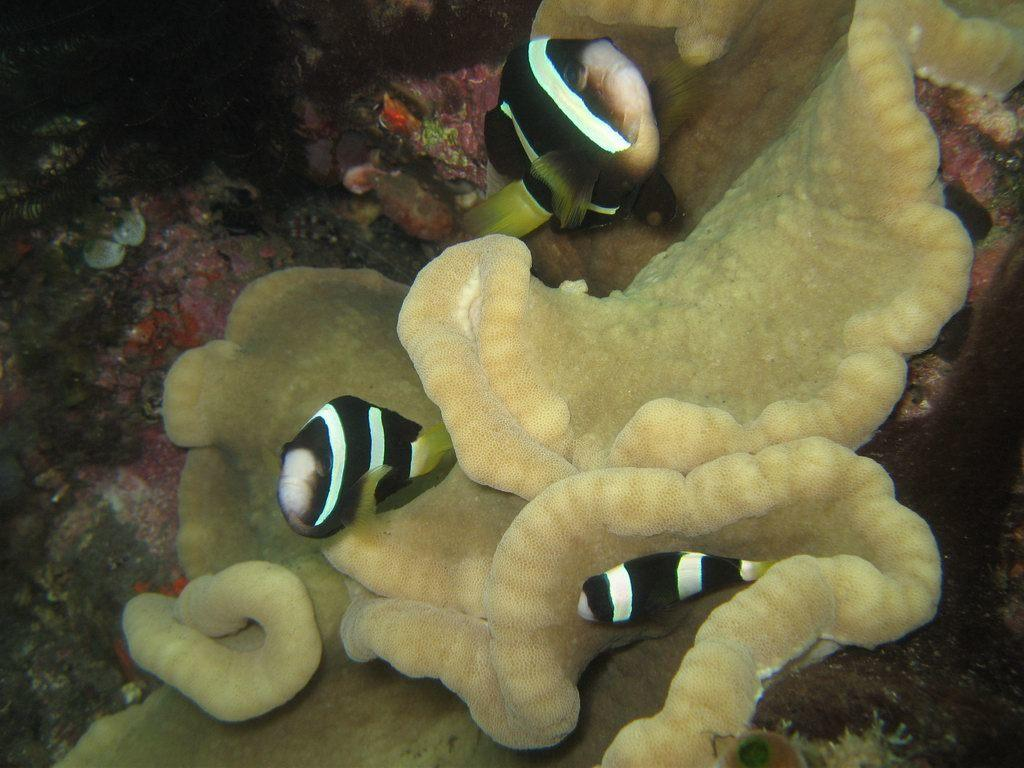What type of animals can be seen in the image? There are fishes swimming in the water. What other objects or structures can be seen in the water? There are stony corals visible. Are there any plants in the image? Yes, aquatic plants are present. How low can the clam dive in the image? There are no clams present in the image, so it is not possible to determine how low they might dive. 